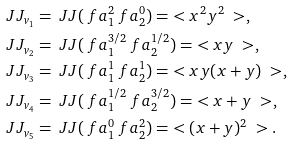Convert formula to latex. <formula><loc_0><loc_0><loc_500><loc_500>\ J J _ { v _ { 1 } } & = \ J J ( \ f a _ { 1 } ^ { 2 } \ f a _ { 2 } ^ { 0 } ) = \ < x ^ { 2 } y ^ { 2 } \ > , \\ \ J J _ { v _ { 2 } } & = \ J J ( \ f a _ { 1 } ^ { 3 / 2 } \ f a _ { 2 } ^ { 1 / 2 } ) = \ < x y \ > , \\ \ J J _ { v _ { 3 } } & = \ J J ( \ f a _ { 1 } ^ { 1 } \ f a _ { 2 } ^ { 1 } ) = \ < x y ( x + y ) \ > , \\ \ J J _ { v _ { 4 } } & = \ J J ( \ f a _ { 1 } ^ { 1 / 2 } \ f a _ { 2 } ^ { 3 / 2 } ) = \ < x + y \ > , \\ \ J J _ { v _ { 5 } } & = \ J J ( \ f a _ { 1 } ^ { 0 } \ f a _ { 2 } ^ { 2 } ) = \ < ( x + y ) ^ { 2 } \ > .</formula> 